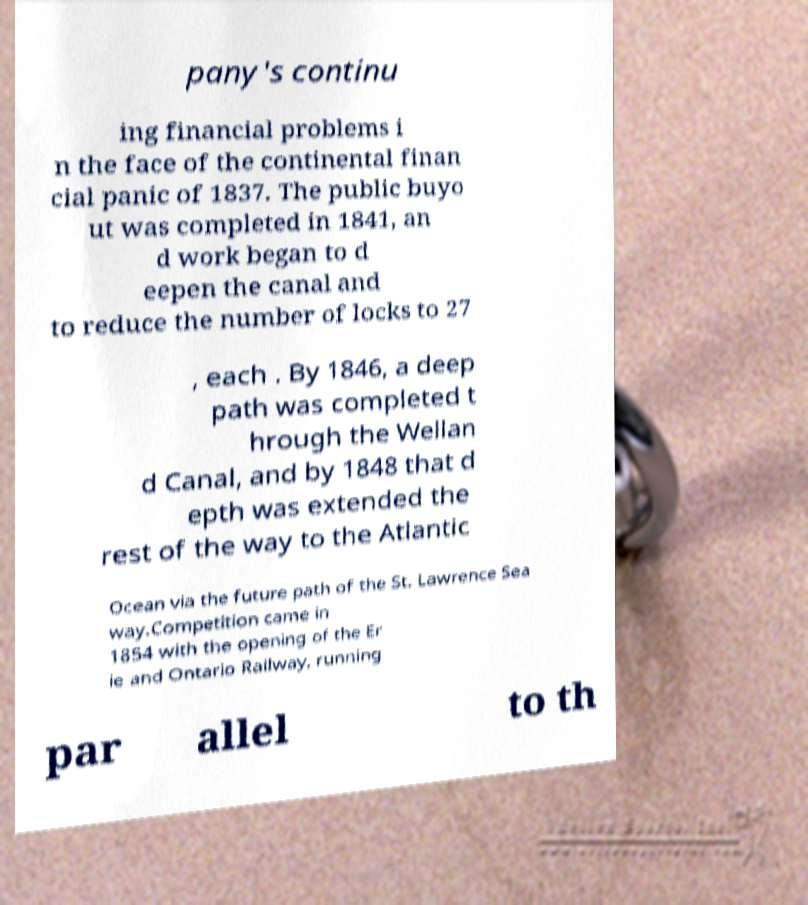I need the written content from this picture converted into text. Can you do that? pany's continu ing financial problems i n the face of the continental finan cial panic of 1837. The public buyo ut was completed in 1841, an d work began to d eepen the canal and to reduce the number of locks to 27 , each . By 1846, a deep path was completed t hrough the Wellan d Canal, and by 1848 that d epth was extended the rest of the way to the Atlantic Ocean via the future path of the St. Lawrence Sea way.Competition came in 1854 with the opening of the Er ie and Ontario Railway, running par allel to th 